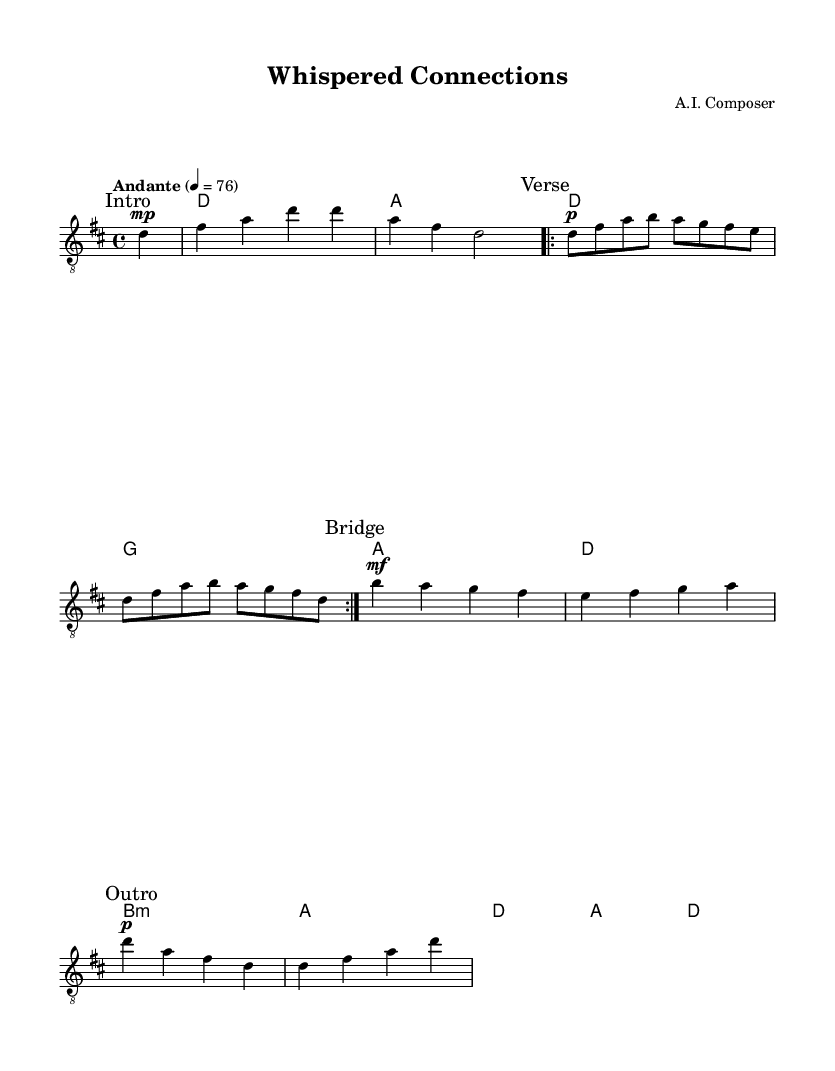What is the key signature of this music? The key signature is D major, indicated by two sharps (F# and C#) on the staff.
Answer: D major What is the time signature of this music? The time signature is represented as 4/4, meaning there are four beats in each measure.
Answer: 4/4 What is the tempo marking for this piece? The tempo marking is "Andante," which indicates a moderate walking pace for the music.
Answer: Andante How many times is the verse repeated? The "Verse" section is marked to be repeated twice, as indicated by the repeat sign.
Answer: 2 times What dynamics are indicated at the beginning of the guitar part? The guitar part starts with a "mp" marking (mezzo-piano), indicating a moderately soft dynamic.
Answer: mezzo-piano Which chord follows the B minor in the harmonies section? After the B minor chord, the next chord indicated is A major.
Answer: A What is the character of the music style indicated by this piece? The piece is characterized as a minimalist acoustic guitar melody, suitable for indie film soundtracks focusing on interpersonal relationships.
Answer: Minimalist acoustic 